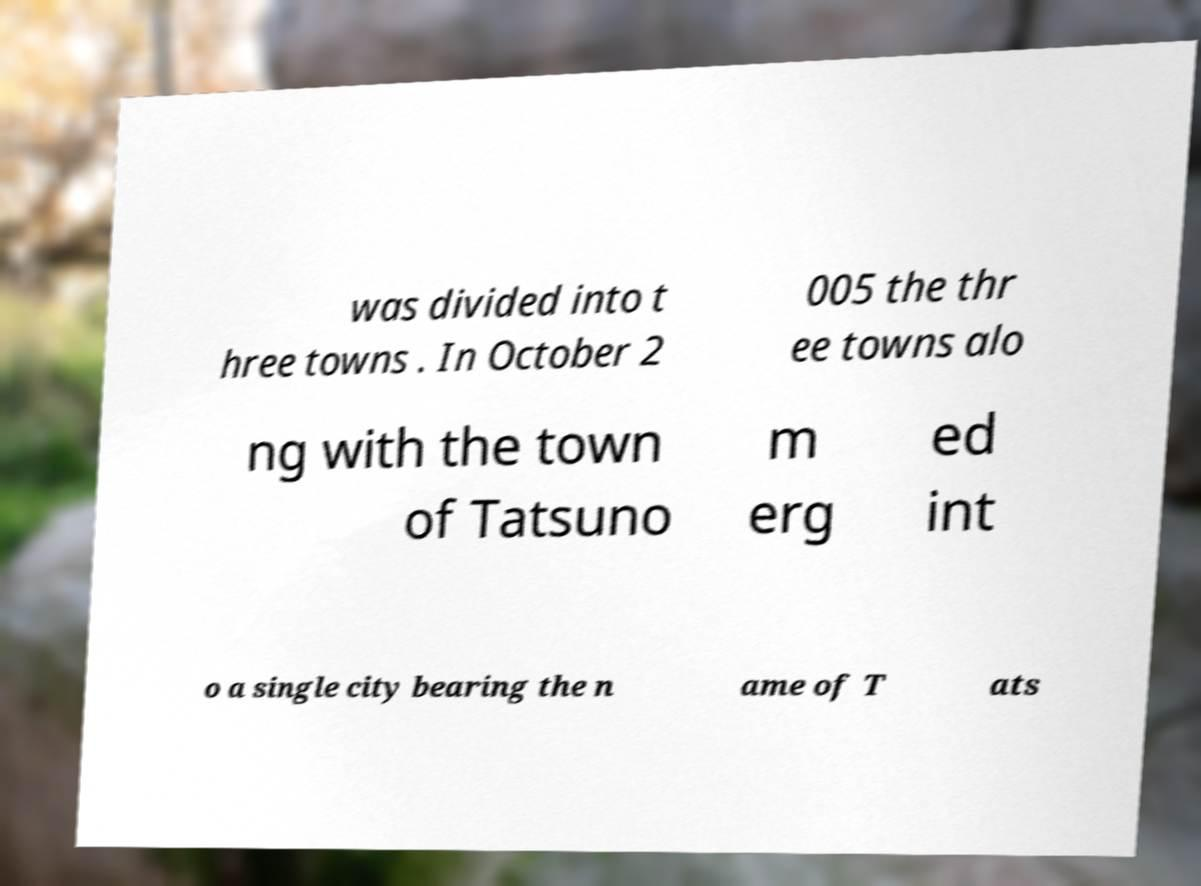Please identify and transcribe the text found in this image. was divided into t hree towns . In October 2 005 the thr ee towns alo ng with the town of Tatsuno m erg ed int o a single city bearing the n ame of T ats 